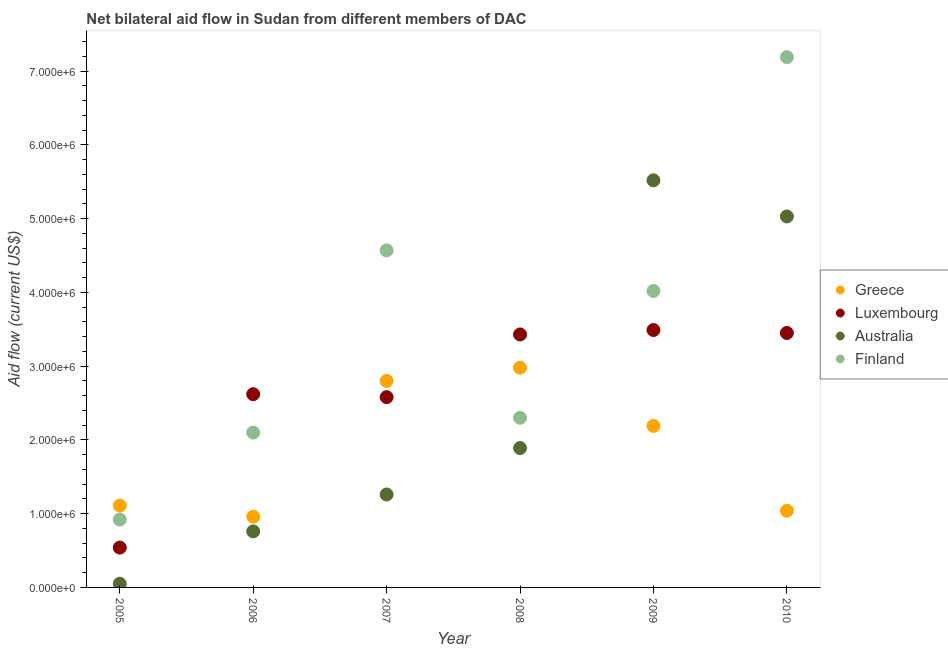How many different coloured dotlines are there?
Ensure brevity in your answer.  4. What is the amount of aid given by greece in 2009?
Your answer should be very brief. 2.19e+06. Across all years, what is the maximum amount of aid given by luxembourg?
Offer a terse response. 3.49e+06. Across all years, what is the minimum amount of aid given by australia?
Your answer should be compact. 5.00e+04. In which year was the amount of aid given by finland maximum?
Offer a very short reply. 2010. In which year was the amount of aid given by luxembourg minimum?
Your answer should be compact. 2005. What is the total amount of aid given by luxembourg in the graph?
Your answer should be very brief. 1.61e+07. What is the difference between the amount of aid given by luxembourg in 2005 and that in 2008?
Offer a terse response. -2.89e+06. What is the difference between the amount of aid given by australia in 2008 and the amount of aid given by finland in 2009?
Ensure brevity in your answer.  -2.13e+06. What is the average amount of aid given by finland per year?
Offer a very short reply. 3.52e+06. In the year 2006, what is the difference between the amount of aid given by australia and amount of aid given by finland?
Offer a terse response. -1.34e+06. What is the ratio of the amount of aid given by australia in 2006 to that in 2008?
Offer a very short reply. 0.4. Is the difference between the amount of aid given by luxembourg in 2007 and 2008 greater than the difference between the amount of aid given by australia in 2007 and 2008?
Provide a succinct answer. No. What is the difference between the highest and the lowest amount of aid given by australia?
Your answer should be compact. 5.47e+06. Is the sum of the amount of aid given by australia in 2005 and 2009 greater than the maximum amount of aid given by greece across all years?
Offer a terse response. Yes. Is it the case that in every year, the sum of the amount of aid given by luxembourg and amount of aid given by finland is greater than the sum of amount of aid given by greece and amount of aid given by australia?
Ensure brevity in your answer.  No. Is it the case that in every year, the sum of the amount of aid given by greece and amount of aid given by luxembourg is greater than the amount of aid given by australia?
Your answer should be very brief. No. Is the amount of aid given by luxembourg strictly greater than the amount of aid given by finland over the years?
Keep it short and to the point. No. Is the amount of aid given by greece strictly less than the amount of aid given by australia over the years?
Give a very brief answer. No. How many dotlines are there?
Ensure brevity in your answer.  4. What is the difference between two consecutive major ticks on the Y-axis?
Your answer should be very brief. 1.00e+06. Are the values on the major ticks of Y-axis written in scientific E-notation?
Give a very brief answer. Yes. Does the graph contain any zero values?
Provide a succinct answer. No. Does the graph contain grids?
Your response must be concise. No. Where does the legend appear in the graph?
Your answer should be very brief. Center right. How many legend labels are there?
Provide a succinct answer. 4. How are the legend labels stacked?
Make the answer very short. Vertical. What is the title of the graph?
Give a very brief answer. Net bilateral aid flow in Sudan from different members of DAC. Does "Social Insurance" appear as one of the legend labels in the graph?
Offer a terse response. No. What is the Aid flow (current US$) of Greece in 2005?
Your answer should be very brief. 1.11e+06. What is the Aid flow (current US$) of Luxembourg in 2005?
Make the answer very short. 5.40e+05. What is the Aid flow (current US$) of Australia in 2005?
Offer a very short reply. 5.00e+04. What is the Aid flow (current US$) of Finland in 2005?
Provide a short and direct response. 9.20e+05. What is the Aid flow (current US$) in Greece in 2006?
Your answer should be very brief. 9.60e+05. What is the Aid flow (current US$) of Luxembourg in 2006?
Your answer should be very brief. 2.62e+06. What is the Aid flow (current US$) in Australia in 2006?
Offer a very short reply. 7.60e+05. What is the Aid flow (current US$) in Finland in 2006?
Make the answer very short. 2.10e+06. What is the Aid flow (current US$) of Greece in 2007?
Your answer should be compact. 2.80e+06. What is the Aid flow (current US$) of Luxembourg in 2007?
Make the answer very short. 2.58e+06. What is the Aid flow (current US$) of Australia in 2007?
Your answer should be compact. 1.26e+06. What is the Aid flow (current US$) of Finland in 2007?
Ensure brevity in your answer.  4.57e+06. What is the Aid flow (current US$) in Greece in 2008?
Offer a very short reply. 2.98e+06. What is the Aid flow (current US$) in Luxembourg in 2008?
Make the answer very short. 3.43e+06. What is the Aid flow (current US$) in Australia in 2008?
Your answer should be compact. 1.89e+06. What is the Aid flow (current US$) of Finland in 2008?
Provide a short and direct response. 2.30e+06. What is the Aid flow (current US$) in Greece in 2009?
Provide a short and direct response. 2.19e+06. What is the Aid flow (current US$) of Luxembourg in 2009?
Provide a short and direct response. 3.49e+06. What is the Aid flow (current US$) in Australia in 2009?
Offer a terse response. 5.52e+06. What is the Aid flow (current US$) of Finland in 2009?
Your answer should be very brief. 4.02e+06. What is the Aid flow (current US$) in Greece in 2010?
Make the answer very short. 1.04e+06. What is the Aid flow (current US$) in Luxembourg in 2010?
Provide a succinct answer. 3.45e+06. What is the Aid flow (current US$) in Australia in 2010?
Provide a succinct answer. 5.03e+06. What is the Aid flow (current US$) of Finland in 2010?
Make the answer very short. 7.19e+06. Across all years, what is the maximum Aid flow (current US$) in Greece?
Your answer should be compact. 2.98e+06. Across all years, what is the maximum Aid flow (current US$) of Luxembourg?
Ensure brevity in your answer.  3.49e+06. Across all years, what is the maximum Aid flow (current US$) in Australia?
Offer a terse response. 5.52e+06. Across all years, what is the maximum Aid flow (current US$) of Finland?
Ensure brevity in your answer.  7.19e+06. Across all years, what is the minimum Aid flow (current US$) of Greece?
Keep it short and to the point. 9.60e+05. Across all years, what is the minimum Aid flow (current US$) of Luxembourg?
Your answer should be very brief. 5.40e+05. Across all years, what is the minimum Aid flow (current US$) of Australia?
Keep it short and to the point. 5.00e+04. Across all years, what is the minimum Aid flow (current US$) in Finland?
Keep it short and to the point. 9.20e+05. What is the total Aid flow (current US$) of Greece in the graph?
Your response must be concise. 1.11e+07. What is the total Aid flow (current US$) in Luxembourg in the graph?
Provide a succinct answer. 1.61e+07. What is the total Aid flow (current US$) of Australia in the graph?
Your answer should be compact. 1.45e+07. What is the total Aid flow (current US$) in Finland in the graph?
Make the answer very short. 2.11e+07. What is the difference between the Aid flow (current US$) of Greece in 2005 and that in 2006?
Your response must be concise. 1.50e+05. What is the difference between the Aid flow (current US$) of Luxembourg in 2005 and that in 2006?
Your response must be concise. -2.08e+06. What is the difference between the Aid flow (current US$) of Australia in 2005 and that in 2006?
Your answer should be very brief. -7.10e+05. What is the difference between the Aid flow (current US$) of Finland in 2005 and that in 2006?
Keep it short and to the point. -1.18e+06. What is the difference between the Aid flow (current US$) in Greece in 2005 and that in 2007?
Make the answer very short. -1.69e+06. What is the difference between the Aid flow (current US$) in Luxembourg in 2005 and that in 2007?
Your answer should be compact. -2.04e+06. What is the difference between the Aid flow (current US$) of Australia in 2005 and that in 2007?
Offer a very short reply. -1.21e+06. What is the difference between the Aid flow (current US$) of Finland in 2005 and that in 2007?
Make the answer very short. -3.65e+06. What is the difference between the Aid flow (current US$) of Greece in 2005 and that in 2008?
Give a very brief answer. -1.87e+06. What is the difference between the Aid flow (current US$) in Luxembourg in 2005 and that in 2008?
Offer a very short reply. -2.89e+06. What is the difference between the Aid flow (current US$) in Australia in 2005 and that in 2008?
Your response must be concise. -1.84e+06. What is the difference between the Aid flow (current US$) of Finland in 2005 and that in 2008?
Give a very brief answer. -1.38e+06. What is the difference between the Aid flow (current US$) of Greece in 2005 and that in 2009?
Give a very brief answer. -1.08e+06. What is the difference between the Aid flow (current US$) in Luxembourg in 2005 and that in 2009?
Offer a very short reply. -2.95e+06. What is the difference between the Aid flow (current US$) of Australia in 2005 and that in 2009?
Provide a short and direct response. -5.47e+06. What is the difference between the Aid flow (current US$) in Finland in 2005 and that in 2009?
Offer a very short reply. -3.10e+06. What is the difference between the Aid flow (current US$) of Greece in 2005 and that in 2010?
Provide a short and direct response. 7.00e+04. What is the difference between the Aid flow (current US$) of Luxembourg in 2005 and that in 2010?
Offer a very short reply. -2.91e+06. What is the difference between the Aid flow (current US$) of Australia in 2005 and that in 2010?
Offer a very short reply. -4.98e+06. What is the difference between the Aid flow (current US$) in Finland in 2005 and that in 2010?
Give a very brief answer. -6.27e+06. What is the difference between the Aid flow (current US$) of Greece in 2006 and that in 2007?
Your answer should be compact. -1.84e+06. What is the difference between the Aid flow (current US$) of Australia in 2006 and that in 2007?
Provide a short and direct response. -5.00e+05. What is the difference between the Aid flow (current US$) of Finland in 2006 and that in 2007?
Keep it short and to the point. -2.47e+06. What is the difference between the Aid flow (current US$) of Greece in 2006 and that in 2008?
Your answer should be very brief. -2.02e+06. What is the difference between the Aid flow (current US$) in Luxembourg in 2006 and that in 2008?
Keep it short and to the point. -8.10e+05. What is the difference between the Aid flow (current US$) in Australia in 2006 and that in 2008?
Your response must be concise. -1.13e+06. What is the difference between the Aid flow (current US$) in Greece in 2006 and that in 2009?
Make the answer very short. -1.23e+06. What is the difference between the Aid flow (current US$) of Luxembourg in 2006 and that in 2009?
Offer a very short reply. -8.70e+05. What is the difference between the Aid flow (current US$) in Australia in 2006 and that in 2009?
Make the answer very short. -4.76e+06. What is the difference between the Aid flow (current US$) of Finland in 2006 and that in 2009?
Ensure brevity in your answer.  -1.92e+06. What is the difference between the Aid flow (current US$) of Luxembourg in 2006 and that in 2010?
Your answer should be very brief. -8.30e+05. What is the difference between the Aid flow (current US$) of Australia in 2006 and that in 2010?
Make the answer very short. -4.27e+06. What is the difference between the Aid flow (current US$) of Finland in 2006 and that in 2010?
Provide a short and direct response. -5.09e+06. What is the difference between the Aid flow (current US$) in Greece in 2007 and that in 2008?
Offer a terse response. -1.80e+05. What is the difference between the Aid flow (current US$) of Luxembourg in 2007 and that in 2008?
Provide a short and direct response. -8.50e+05. What is the difference between the Aid flow (current US$) of Australia in 2007 and that in 2008?
Provide a succinct answer. -6.30e+05. What is the difference between the Aid flow (current US$) in Finland in 2007 and that in 2008?
Offer a terse response. 2.27e+06. What is the difference between the Aid flow (current US$) in Greece in 2007 and that in 2009?
Provide a succinct answer. 6.10e+05. What is the difference between the Aid flow (current US$) in Luxembourg in 2007 and that in 2009?
Give a very brief answer. -9.10e+05. What is the difference between the Aid flow (current US$) in Australia in 2007 and that in 2009?
Provide a succinct answer. -4.26e+06. What is the difference between the Aid flow (current US$) of Greece in 2007 and that in 2010?
Provide a short and direct response. 1.76e+06. What is the difference between the Aid flow (current US$) in Luxembourg in 2007 and that in 2010?
Keep it short and to the point. -8.70e+05. What is the difference between the Aid flow (current US$) of Australia in 2007 and that in 2010?
Provide a short and direct response. -3.77e+06. What is the difference between the Aid flow (current US$) of Finland in 2007 and that in 2010?
Make the answer very short. -2.62e+06. What is the difference between the Aid flow (current US$) in Greece in 2008 and that in 2009?
Offer a very short reply. 7.90e+05. What is the difference between the Aid flow (current US$) of Luxembourg in 2008 and that in 2009?
Provide a succinct answer. -6.00e+04. What is the difference between the Aid flow (current US$) of Australia in 2008 and that in 2009?
Keep it short and to the point. -3.63e+06. What is the difference between the Aid flow (current US$) in Finland in 2008 and that in 2009?
Provide a short and direct response. -1.72e+06. What is the difference between the Aid flow (current US$) of Greece in 2008 and that in 2010?
Your answer should be compact. 1.94e+06. What is the difference between the Aid flow (current US$) of Australia in 2008 and that in 2010?
Make the answer very short. -3.14e+06. What is the difference between the Aid flow (current US$) of Finland in 2008 and that in 2010?
Your response must be concise. -4.89e+06. What is the difference between the Aid flow (current US$) of Greece in 2009 and that in 2010?
Keep it short and to the point. 1.15e+06. What is the difference between the Aid flow (current US$) of Australia in 2009 and that in 2010?
Ensure brevity in your answer.  4.90e+05. What is the difference between the Aid flow (current US$) of Finland in 2009 and that in 2010?
Ensure brevity in your answer.  -3.17e+06. What is the difference between the Aid flow (current US$) of Greece in 2005 and the Aid flow (current US$) of Luxembourg in 2006?
Your answer should be compact. -1.51e+06. What is the difference between the Aid flow (current US$) in Greece in 2005 and the Aid flow (current US$) in Australia in 2006?
Your answer should be very brief. 3.50e+05. What is the difference between the Aid flow (current US$) of Greece in 2005 and the Aid flow (current US$) of Finland in 2006?
Ensure brevity in your answer.  -9.90e+05. What is the difference between the Aid flow (current US$) of Luxembourg in 2005 and the Aid flow (current US$) of Finland in 2006?
Ensure brevity in your answer.  -1.56e+06. What is the difference between the Aid flow (current US$) of Australia in 2005 and the Aid flow (current US$) of Finland in 2006?
Ensure brevity in your answer.  -2.05e+06. What is the difference between the Aid flow (current US$) of Greece in 2005 and the Aid flow (current US$) of Luxembourg in 2007?
Offer a very short reply. -1.47e+06. What is the difference between the Aid flow (current US$) of Greece in 2005 and the Aid flow (current US$) of Australia in 2007?
Make the answer very short. -1.50e+05. What is the difference between the Aid flow (current US$) in Greece in 2005 and the Aid flow (current US$) in Finland in 2007?
Provide a short and direct response. -3.46e+06. What is the difference between the Aid flow (current US$) in Luxembourg in 2005 and the Aid flow (current US$) in Australia in 2007?
Make the answer very short. -7.20e+05. What is the difference between the Aid flow (current US$) in Luxembourg in 2005 and the Aid flow (current US$) in Finland in 2007?
Offer a terse response. -4.03e+06. What is the difference between the Aid flow (current US$) in Australia in 2005 and the Aid flow (current US$) in Finland in 2007?
Provide a short and direct response. -4.52e+06. What is the difference between the Aid flow (current US$) in Greece in 2005 and the Aid flow (current US$) in Luxembourg in 2008?
Keep it short and to the point. -2.32e+06. What is the difference between the Aid flow (current US$) in Greece in 2005 and the Aid flow (current US$) in Australia in 2008?
Your response must be concise. -7.80e+05. What is the difference between the Aid flow (current US$) in Greece in 2005 and the Aid flow (current US$) in Finland in 2008?
Your answer should be very brief. -1.19e+06. What is the difference between the Aid flow (current US$) of Luxembourg in 2005 and the Aid flow (current US$) of Australia in 2008?
Provide a succinct answer. -1.35e+06. What is the difference between the Aid flow (current US$) in Luxembourg in 2005 and the Aid flow (current US$) in Finland in 2008?
Offer a very short reply. -1.76e+06. What is the difference between the Aid flow (current US$) in Australia in 2005 and the Aid flow (current US$) in Finland in 2008?
Provide a succinct answer. -2.25e+06. What is the difference between the Aid flow (current US$) in Greece in 2005 and the Aid flow (current US$) in Luxembourg in 2009?
Provide a succinct answer. -2.38e+06. What is the difference between the Aid flow (current US$) of Greece in 2005 and the Aid flow (current US$) of Australia in 2009?
Make the answer very short. -4.41e+06. What is the difference between the Aid flow (current US$) in Greece in 2005 and the Aid flow (current US$) in Finland in 2009?
Your response must be concise. -2.91e+06. What is the difference between the Aid flow (current US$) of Luxembourg in 2005 and the Aid flow (current US$) of Australia in 2009?
Your answer should be very brief. -4.98e+06. What is the difference between the Aid flow (current US$) in Luxembourg in 2005 and the Aid flow (current US$) in Finland in 2009?
Provide a succinct answer. -3.48e+06. What is the difference between the Aid flow (current US$) in Australia in 2005 and the Aid flow (current US$) in Finland in 2009?
Your answer should be compact. -3.97e+06. What is the difference between the Aid flow (current US$) in Greece in 2005 and the Aid flow (current US$) in Luxembourg in 2010?
Provide a succinct answer. -2.34e+06. What is the difference between the Aid flow (current US$) of Greece in 2005 and the Aid flow (current US$) of Australia in 2010?
Provide a short and direct response. -3.92e+06. What is the difference between the Aid flow (current US$) of Greece in 2005 and the Aid flow (current US$) of Finland in 2010?
Keep it short and to the point. -6.08e+06. What is the difference between the Aid flow (current US$) in Luxembourg in 2005 and the Aid flow (current US$) in Australia in 2010?
Offer a terse response. -4.49e+06. What is the difference between the Aid flow (current US$) of Luxembourg in 2005 and the Aid flow (current US$) of Finland in 2010?
Offer a very short reply. -6.65e+06. What is the difference between the Aid flow (current US$) in Australia in 2005 and the Aid flow (current US$) in Finland in 2010?
Offer a terse response. -7.14e+06. What is the difference between the Aid flow (current US$) of Greece in 2006 and the Aid flow (current US$) of Luxembourg in 2007?
Your response must be concise. -1.62e+06. What is the difference between the Aid flow (current US$) in Greece in 2006 and the Aid flow (current US$) in Finland in 2007?
Keep it short and to the point. -3.61e+06. What is the difference between the Aid flow (current US$) of Luxembourg in 2006 and the Aid flow (current US$) of Australia in 2007?
Give a very brief answer. 1.36e+06. What is the difference between the Aid flow (current US$) of Luxembourg in 2006 and the Aid flow (current US$) of Finland in 2007?
Make the answer very short. -1.95e+06. What is the difference between the Aid flow (current US$) in Australia in 2006 and the Aid flow (current US$) in Finland in 2007?
Offer a terse response. -3.81e+06. What is the difference between the Aid flow (current US$) of Greece in 2006 and the Aid flow (current US$) of Luxembourg in 2008?
Make the answer very short. -2.47e+06. What is the difference between the Aid flow (current US$) in Greece in 2006 and the Aid flow (current US$) in Australia in 2008?
Offer a very short reply. -9.30e+05. What is the difference between the Aid flow (current US$) in Greece in 2006 and the Aid flow (current US$) in Finland in 2008?
Your response must be concise. -1.34e+06. What is the difference between the Aid flow (current US$) of Luxembourg in 2006 and the Aid flow (current US$) of Australia in 2008?
Give a very brief answer. 7.30e+05. What is the difference between the Aid flow (current US$) of Luxembourg in 2006 and the Aid flow (current US$) of Finland in 2008?
Offer a terse response. 3.20e+05. What is the difference between the Aid flow (current US$) in Australia in 2006 and the Aid flow (current US$) in Finland in 2008?
Your response must be concise. -1.54e+06. What is the difference between the Aid flow (current US$) in Greece in 2006 and the Aid flow (current US$) in Luxembourg in 2009?
Your answer should be very brief. -2.53e+06. What is the difference between the Aid flow (current US$) of Greece in 2006 and the Aid flow (current US$) of Australia in 2009?
Offer a very short reply. -4.56e+06. What is the difference between the Aid flow (current US$) in Greece in 2006 and the Aid flow (current US$) in Finland in 2009?
Provide a short and direct response. -3.06e+06. What is the difference between the Aid flow (current US$) in Luxembourg in 2006 and the Aid flow (current US$) in Australia in 2009?
Provide a succinct answer. -2.90e+06. What is the difference between the Aid flow (current US$) in Luxembourg in 2006 and the Aid flow (current US$) in Finland in 2009?
Offer a very short reply. -1.40e+06. What is the difference between the Aid flow (current US$) of Australia in 2006 and the Aid flow (current US$) of Finland in 2009?
Offer a very short reply. -3.26e+06. What is the difference between the Aid flow (current US$) in Greece in 2006 and the Aid flow (current US$) in Luxembourg in 2010?
Keep it short and to the point. -2.49e+06. What is the difference between the Aid flow (current US$) in Greece in 2006 and the Aid flow (current US$) in Australia in 2010?
Keep it short and to the point. -4.07e+06. What is the difference between the Aid flow (current US$) in Greece in 2006 and the Aid flow (current US$) in Finland in 2010?
Your answer should be compact. -6.23e+06. What is the difference between the Aid flow (current US$) of Luxembourg in 2006 and the Aid flow (current US$) of Australia in 2010?
Your answer should be very brief. -2.41e+06. What is the difference between the Aid flow (current US$) in Luxembourg in 2006 and the Aid flow (current US$) in Finland in 2010?
Make the answer very short. -4.57e+06. What is the difference between the Aid flow (current US$) of Australia in 2006 and the Aid flow (current US$) of Finland in 2010?
Your response must be concise. -6.43e+06. What is the difference between the Aid flow (current US$) in Greece in 2007 and the Aid flow (current US$) in Luxembourg in 2008?
Your response must be concise. -6.30e+05. What is the difference between the Aid flow (current US$) of Greece in 2007 and the Aid flow (current US$) of Australia in 2008?
Offer a very short reply. 9.10e+05. What is the difference between the Aid flow (current US$) of Luxembourg in 2007 and the Aid flow (current US$) of Australia in 2008?
Offer a very short reply. 6.90e+05. What is the difference between the Aid flow (current US$) in Australia in 2007 and the Aid flow (current US$) in Finland in 2008?
Ensure brevity in your answer.  -1.04e+06. What is the difference between the Aid flow (current US$) of Greece in 2007 and the Aid flow (current US$) of Luxembourg in 2009?
Ensure brevity in your answer.  -6.90e+05. What is the difference between the Aid flow (current US$) of Greece in 2007 and the Aid flow (current US$) of Australia in 2009?
Offer a terse response. -2.72e+06. What is the difference between the Aid flow (current US$) in Greece in 2007 and the Aid flow (current US$) in Finland in 2009?
Provide a short and direct response. -1.22e+06. What is the difference between the Aid flow (current US$) of Luxembourg in 2007 and the Aid flow (current US$) of Australia in 2009?
Offer a very short reply. -2.94e+06. What is the difference between the Aid flow (current US$) in Luxembourg in 2007 and the Aid flow (current US$) in Finland in 2009?
Your answer should be very brief. -1.44e+06. What is the difference between the Aid flow (current US$) in Australia in 2007 and the Aid flow (current US$) in Finland in 2009?
Keep it short and to the point. -2.76e+06. What is the difference between the Aid flow (current US$) of Greece in 2007 and the Aid flow (current US$) of Luxembourg in 2010?
Offer a terse response. -6.50e+05. What is the difference between the Aid flow (current US$) of Greece in 2007 and the Aid flow (current US$) of Australia in 2010?
Give a very brief answer. -2.23e+06. What is the difference between the Aid flow (current US$) of Greece in 2007 and the Aid flow (current US$) of Finland in 2010?
Make the answer very short. -4.39e+06. What is the difference between the Aid flow (current US$) in Luxembourg in 2007 and the Aid flow (current US$) in Australia in 2010?
Your answer should be very brief. -2.45e+06. What is the difference between the Aid flow (current US$) in Luxembourg in 2007 and the Aid flow (current US$) in Finland in 2010?
Your answer should be very brief. -4.61e+06. What is the difference between the Aid flow (current US$) in Australia in 2007 and the Aid flow (current US$) in Finland in 2010?
Your answer should be compact. -5.93e+06. What is the difference between the Aid flow (current US$) of Greece in 2008 and the Aid flow (current US$) of Luxembourg in 2009?
Make the answer very short. -5.10e+05. What is the difference between the Aid flow (current US$) in Greece in 2008 and the Aid flow (current US$) in Australia in 2009?
Make the answer very short. -2.54e+06. What is the difference between the Aid flow (current US$) in Greece in 2008 and the Aid flow (current US$) in Finland in 2009?
Your answer should be compact. -1.04e+06. What is the difference between the Aid flow (current US$) of Luxembourg in 2008 and the Aid flow (current US$) of Australia in 2009?
Provide a succinct answer. -2.09e+06. What is the difference between the Aid flow (current US$) of Luxembourg in 2008 and the Aid flow (current US$) of Finland in 2009?
Your answer should be compact. -5.90e+05. What is the difference between the Aid flow (current US$) of Australia in 2008 and the Aid flow (current US$) of Finland in 2009?
Offer a terse response. -2.13e+06. What is the difference between the Aid flow (current US$) of Greece in 2008 and the Aid flow (current US$) of Luxembourg in 2010?
Your answer should be very brief. -4.70e+05. What is the difference between the Aid flow (current US$) of Greece in 2008 and the Aid flow (current US$) of Australia in 2010?
Offer a very short reply. -2.05e+06. What is the difference between the Aid flow (current US$) in Greece in 2008 and the Aid flow (current US$) in Finland in 2010?
Ensure brevity in your answer.  -4.21e+06. What is the difference between the Aid flow (current US$) of Luxembourg in 2008 and the Aid flow (current US$) of Australia in 2010?
Offer a very short reply. -1.60e+06. What is the difference between the Aid flow (current US$) in Luxembourg in 2008 and the Aid flow (current US$) in Finland in 2010?
Ensure brevity in your answer.  -3.76e+06. What is the difference between the Aid flow (current US$) of Australia in 2008 and the Aid flow (current US$) of Finland in 2010?
Offer a very short reply. -5.30e+06. What is the difference between the Aid flow (current US$) in Greece in 2009 and the Aid flow (current US$) in Luxembourg in 2010?
Offer a very short reply. -1.26e+06. What is the difference between the Aid flow (current US$) of Greece in 2009 and the Aid flow (current US$) of Australia in 2010?
Ensure brevity in your answer.  -2.84e+06. What is the difference between the Aid flow (current US$) in Greece in 2009 and the Aid flow (current US$) in Finland in 2010?
Give a very brief answer. -5.00e+06. What is the difference between the Aid flow (current US$) in Luxembourg in 2009 and the Aid flow (current US$) in Australia in 2010?
Your answer should be very brief. -1.54e+06. What is the difference between the Aid flow (current US$) of Luxembourg in 2009 and the Aid flow (current US$) of Finland in 2010?
Provide a succinct answer. -3.70e+06. What is the difference between the Aid flow (current US$) in Australia in 2009 and the Aid flow (current US$) in Finland in 2010?
Make the answer very short. -1.67e+06. What is the average Aid flow (current US$) of Greece per year?
Provide a short and direct response. 1.85e+06. What is the average Aid flow (current US$) of Luxembourg per year?
Your answer should be very brief. 2.68e+06. What is the average Aid flow (current US$) in Australia per year?
Provide a short and direct response. 2.42e+06. What is the average Aid flow (current US$) in Finland per year?
Provide a succinct answer. 3.52e+06. In the year 2005, what is the difference between the Aid flow (current US$) of Greece and Aid flow (current US$) of Luxembourg?
Make the answer very short. 5.70e+05. In the year 2005, what is the difference between the Aid flow (current US$) in Greece and Aid flow (current US$) in Australia?
Give a very brief answer. 1.06e+06. In the year 2005, what is the difference between the Aid flow (current US$) of Greece and Aid flow (current US$) of Finland?
Make the answer very short. 1.90e+05. In the year 2005, what is the difference between the Aid flow (current US$) of Luxembourg and Aid flow (current US$) of Australia?
Your answer should be very brief. 4.90e+05. In the year 2005, what is the difference between the Aid flow (current US$) of Luxembourg and Aid flow (current US$) of Finland?
Offer a very short reply. -3.80e+05. In the year 2005, what is the difference between the Aid flow (current US$) of Australia and Aid flow (current US$) of Finland?
Offer a very short reply. -8.70e+05. In the year 2006, what is the difference between the Aid flow (current US$) in Greece and Aid flow (current US$) in Luxembourg?
Ensure brevity in your answer.  -1.66e+06. In the year 2006, what is the difference between the Aid flow (current US$) in Greece and Aid flow (current US$) in Australia?
Offer a terse response. 2.00e+05. In the year 2006, what is the difference between the Aid flow (current US$) in Greece and Aid flow (current US$) in Finland?
Provide a succinct answer. -1.14e+06. In the year 2006, what is the difference between the Aid flow (current US$) in Luxembourg and Aid flow (current US$) in Australia?
Keep it short and to the point. 1.86e+06. In the year 2006, what is the difference between the Aid flow (current US$) of Luxembourg and Aid flow (current US$) of Finland?
Your answer should be very brief. 5.20e+05. In the year 2006, what is the difference between the Aid flow (current US$) of Australia and Aid flow (current US$) of Finland?
Ensure brevity in your answer.  -1.34e+06. In the year 2007, what is the difference between the Aid flow (current US$) in Greece and Aid flow (current US$) in Australia?
Give a very brief answer. 1.54e+06. In the year 2007, what is the difference between the Aid flow (current US$) of Greece and Aid flow (current US$) of Finland?
Ensure brevity in your answer.  -1.77e+06. In the year 2007, what is the difference between the Aid flow (current US$) in Luxembourg and Aid flow (current US$) in Australia?
Give a very brief answer. 1.32e+06. In the year 2007, what is the difference between the Aid flow (current US$) of Luxembourg and Aid flow (current US$) of Finland?
Keep it short and to the point. -1.99e+06. In the year 2007, what is the difference between the Aid flow (current US$) in Australia and Aid flow (current US$) in Finland?
Keep it short and to the point. -3.31e+06. In the year 2008, what is the difference between the Aid flow (current US$) of Greece and Aid flow (current US$) of Luxembourg?
Your answer should be very brief. -4.50e+05. In the year 2008, what is the difference between the Aid flow (current US$) of Greece and Aid flow (current US$) of Australia?
Offer a terse response. 1.09e+06. In the year 2008, what is the difference between the Aid flow (current US$) of Greece and Aid flow (current US$) of Finland?
Ensure brevity in your answer.  6.80e+05. In the year 2008, what is the difference between the Aid flow (current US$) in Luxembourg and Aid flow (current US$) in Australia?
Ensure brevity in your answer.  1.54e+06. In the year 2008, what is the difference between the Aid flow (current US$) in Luxembourg and Aid flow (current US$) in Finland?
Give a very brief answer. 1.13e+06. In the year 2008, what is the difference between the Aid flow (current US$) of Australia and Aid flow (current US$) of Finland?
Ensure brevity in your answer.  -4.10e+05. In the year 2009, what is the difference between the Aid flow (current US$) of Greece and Aid flow (current US$) of Luxembourg?
Your answer should be very brief. -1.30e+06. In the year 2009, what is the difference between the Aid flow (current US$) in Greece and Aid flow (current US$) in Australia?
Your answer should be very brief. -3.33e+06. In the year 2009, what is the difference between the Aid flow (current US$) in Greece and Aid flow (current US$) in Finland?
Keep it short and to the point. -1.83e+06. In the year 2009, what is the difference between the Aid flow (current US$) of Luxembourg and Aid flow (current US$) of Australia?
Your response must be concise. -2.03e+06. In the year 2009, what is the difference between the Aid flow (current US$) of Luxembourg and Aid flow (current US$) of Finland?
Offer a terse response. -5.30e+05. In the year 2009, what is the difference between the Aid flow (current US$) of Australia and Aid flow (current US$) of Finland?
Your response must be concise. 1.50e+06. In the year 2010, what is the difference between the Aid flow (current US$) of Greece and Aid flow (current US$) of Luxembourg?
Your answer should be compact. -2.41e+06. In the year 2010, what is the difference between the Aid flow (current US$) in Greece and Aid flow (current US$) in Australia?
Keep it short and to the point. -3.99e+06. In the year 2010, what is the difference between the Aid flow (current US$) of Greece and Aid flow (current US$) of Finland?
Provide a short and direct response. -6.15e+06. In the year 2010, what is the difference between the Aid flow (current US$) in Luxembourg and Aid flow (current US$) in Australia?
Your response must be concise. -1.58e+06. In the year 2010, what is the difference between the Aid flow (current US$) of Luxembourg and Aid flow (current US$) of Finland?
Your answer should be very brief. -3.74e+06. In the year 2010, what is the difference between the Aid flow (current US$) in Australia and Aid flow (current US$) in Finland?
Your answer should be very brief. -2.16e+06. What is the ratio of the Aid flow (current US$) of Greece in 2005 to that in 2006?
Offer a terse response. 1.16. What is the ratio of the Aid flow (current US$) in Luxembourg in 2005 to that in 2006?
Keep it short and to the point. 0.21. What is the ratio of the Aid flow (current US$) in Australia in 2005 to that in 2006?
Ensure brevity in your answer.  0.07. What is the ratio of the Aid flow (current US$) in Finland in 2005 to that in 2006?
Keep it short and to the point. 0.44. What is the ratio of the Aid flow (current US$) of Greece in 2005 to that in 2007?
Keep it short and to the point. 0.4. What is the ratio of the Aid flow (current US$) in Luxembourg in 2005 to that in 2007?
Keep it short and to the point. 0.21. What is the ratio of the Aid flow (current US$) in Australia in 2005 to that in 2007?
Provide a succinct answer. 0.04. What is the ratio of the Aid flow (current US$) in Finland in 2005 to that in 2007?
Ensure brevity in your answer.  0.2. What is the ratio of the Aid flow (current US$) in Greece in 2005 to that in 2008?
Give a very brief answer. 0.37. What is the ratio of the Aid flow (current US$) of Luxembourg in 2005 to that in 2008?
Provide a short and direct response. 0.16. What is the ratio of the Aid flow (current US$) in Australia in 2005 to that in 2008?
Ensure brevity in your answer.  0.03. What is the ratio of the Aid flow (current US$) of Greece in 2005 to that in 2009?
Keep it short and to the point. 0.51. What is the ratio of the Aid flow (current US$) of Luxembourg in 2005 to that in 2009?
Your answer should be very brief. 0.15. What is the ratio of the Aid flow (current US$) of Australia in 2005 to that in 2009?
Give a very brief answer. 0.01. What is the ratio of the Aid flow (current US$) of Finland in 2005 to that in 2009?
Your answer should be compact. 0.23. What is the ratio of the Aid flow (current US$) of Greece in 2005 to that in 2010?
Your answer should be compact. 1.07. What is the ratio of the Aid flow (current US$) of Luxembourg in 2005 to that in 2010?
Make the answer very short. 0.16. What is the ratio of the Aid flow (current US$) in Australia in 2005 to that in 2010?
Your response must be concise. 0.01. What is the ratio of the Aid flow (current US$) of Finland in 2005 to that in 2010?
Offer a very short reply. 0.13. What is the ratio of the Aid flow (current US$) of Greece in 2006 to that in 2007?
Give a very brief answer. 0.34. What is the ratio of the Aid flow (current US$) in Luxembourg in 2006 to that in 2007?
Offer a very short reply. 1.02. What is the ratio of the Aid flow (current US$) in Australia in 2006 to that in 2007?
Keep it short and to the point. 0.6. What is the ratio of the Aid flow (current US$) in Finland in 2006 to that in 2007?
Your answer should be compact. 0.46. What is the ratio of the Aid flow (current US$) in Greece in 2006 to that in 2008?
Provide a short and direct response. 0.32. What is the ratio of the Aid flow (current US$) of Luxembourg in 2006 to that in 2008?
Provide a succinct answer. 0.76. What is the ratio of the Aid flow (current US$) in Australia in 2006 to that in 2008?
Your response must be concise. 0.4. What is the ratio of the Aid flow (current US$) in Greece in 2006 to that in 2009?
Your answer should be very brief. 0.44. What is the ratio of the Aid flow (current US$) of Luxembourg in 2006 to that in 2009?
Keep it short and to the point. 0.75. What is the ratio of the Aid flow (current US$) of Australia in 2006 to that in 2009?
Offer a terse response. 0.14. What is the ratio of the Aid flow (current US$) of Finland in 2006 to that in 2009?
Your answer should be compact. 0.52. What is the ratio of the Aid flow (current US$) of Luxembourg in 2006 to that in 2010?
Give a very brief answer. 0.76. What is the ratio of the Aid flow (current US$) in Australia in 2006 to that in 2010?
Your answer should be very brief. 0.15. What is the ratio of the Aid flow (current US$) in Finland in 2006 to that in 2010?
Provide a short and direct response. 0.29. What is the ratio of the Aid flow (current US$) of Greece in 2007 to that in 2008?
Provide a short and direct response. 0.94. What is the ratio of the Aid flow (current US$) of Luxembourg in 2007 to that in 2008?
Offer a very short reply. 0.75. What is the ratio of the Aid flow (current US$) of Finland in 2007 to that in 2008?
Offer a very short reply. 1.99. What is the ratio of the Aid flow (current US$) in Greece in 2007 to that in 2009?
Offer a terse response. 1.28. What is the ratio of the Aid flow (current US$) in Luxembourg in 2007 to that in 2009?
Give a very brief answer. 0.74. What is the ratio of the Aid flow (current US$) of Australia in 2007 to that in 2009?
Make the answer very short. 0.23. What is the ratio of the Aid flow (current US$) in Finland in 2007 to that in 2009?
Make the answer very short. 1.14. What is the ratio of the Aid flow (current US$) in Greece in 2007 to that in 2010?
Make the answer very short. 2.69. What is the ratio of the Aid flow (current US$) in Luxembourg in 2007 to that in 2010?
Make the answer very short. 0.75. What is the ratio of the Aid flow (current US$) in Australia in 2007 to that in 2010?
Your answer should be compact. 0.25. What is the ratio of the Aid flow (current US$) in Finland in 2007 to that in 2010?
Provide a succinct answer. 0.64. What is the ratio of the Aid flow (current US$) in Greece in 2008 to that in 2009?
Your answer should be very brief. 1.36. What is the ratio of the Aid flow (current US$) in Luxembourg in 2008 to that in 2009?
Provide a short and direct response. 0.98. What is the ratio of the Aid flow (current US$) of Australia in 2008 to that in 2009?
Keep it short and to the point. 0.34. What is the ratio of the Aid flow (current US$) of Finland in 2008 to that in 2009?
Provide a succinct answer. 0.57. What is the ratio of the Aid flow (current US$) of Greece in 2008 to that in 2010?
Ensure brevity in your answer.  2.87. What is the ratio of the Aid flow (current US$) in Luxembourg in 2008 to that in 2010?
Keep it short and to the point. 0.99. What is the ratio of the Aid flow (current US$) of Australia in 2008 to that in 2010?
Your response must be concise. 0.38. What is the ratio of the Aid flow (current US$) of Finland in 2008 to that in 2010?
Your answer should be very brief. 0.32. What is the ratio of the Aid flow (current US$) of Greece in 2009 to that in 2010?
Your answer should be compact. 2.11. What is the ratio of the Aid flow (current US$) in Luxembourg in 2009 to that in 2010?
Give a very brief answer. 1.01. What is the ratio of the Aid flow (current US$) of Australia in 2009 to that in 2010?
Ensure brevity in your answer.  1.1. What is the ratio of the Aid flow (current US$) in Finland in 2009 to that in 2010?
Your response must be concise. 0.56. What is the difference between the highest and the second highest Aid flow (current US$) of Greece?
Ensure brevity in your answer.  1.80e+05. What is the difference between the highest and the second highest Aid flow (current US$) in Australia?
Give a very brief answer. 4.90e+05. What is the difference between the highest and the second highest Aid flow (current US$) in Finland?
Keep it short and to the point. 2.62e+06. What is the difference between the highest and the lowest Aid flow (current US$) of Greece?
Your answer should be compact. 2.02e+06. What is the difference between the highest and the lowest Aid flow (current US$) in Luxembourg?
Offer a terse response. 2.95e+06. What is the difference between the highest and the lowest Aid flow (current US$) of Australia?
Offer a terse response. 5.47e+06. What is the difference between the highest and the lowest Aid flow (current US$) of Finland?
Provide a short and direct response. 6.27e+06. 